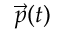<formula> <loc_0><loc_0><loc_500><loc_500>\vec { p } ( t )</formula> 